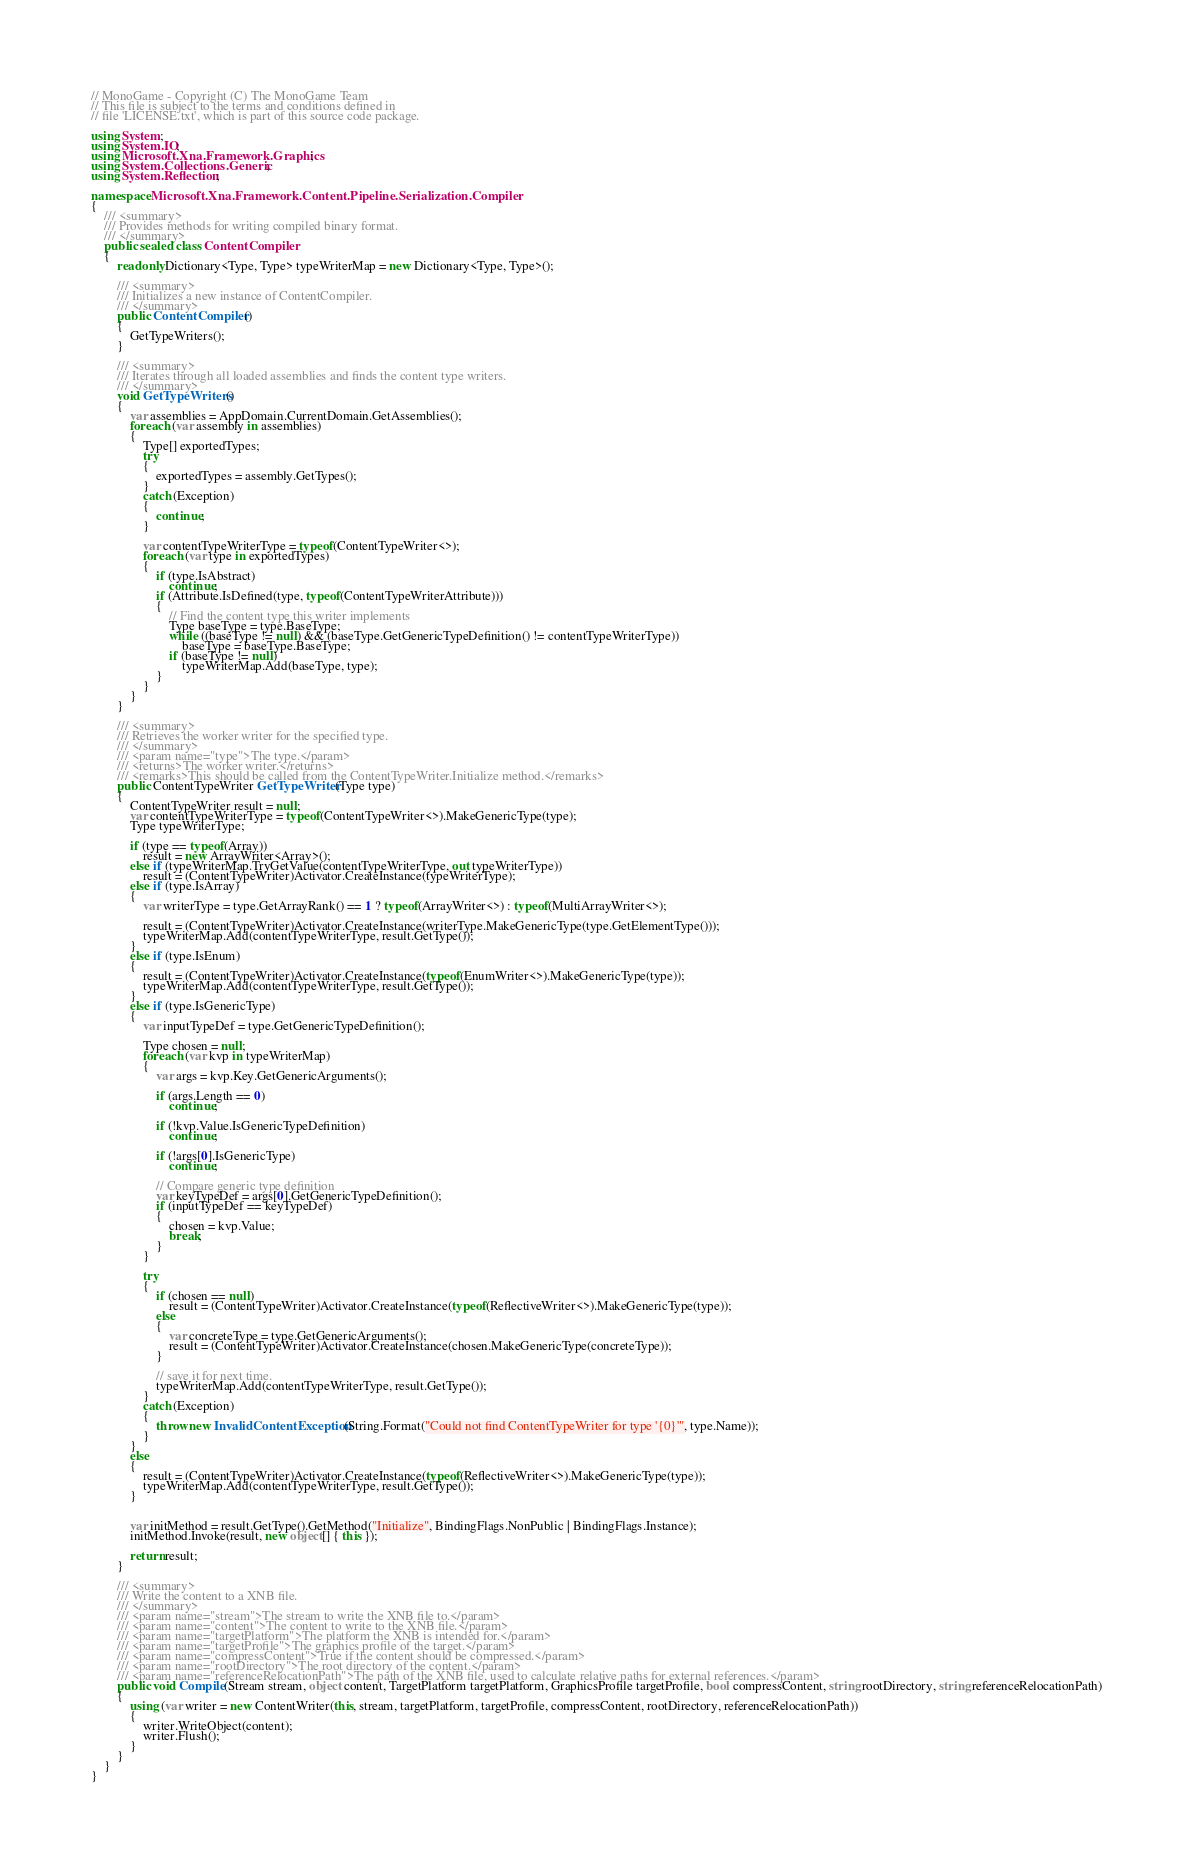Convert code to text. <code><loc_0><loc_0><loc_500><loc_500><_C#_>// MonoGame - Copyright (C) The MonoGame Team
// This file is subject to the terms and conditions defined in
// file 'LICENSE.txt', which is part of this source code package.

using System;
using System.IO;
using Microsoft.Xna.Framework.Graphics;
using System.Collections.Generic;
using System.Reflection;

namespace Microsoft.Xna.Framework.Content.Pipeline.Serialization.Compiler
{
    /// <summary>
    /// Provides methods for writing compiled binary format.
    /// </summary>
    public sealed class ContentCompiler
    {
        readonly Dictionary<Type, Type> typeWriterMap = new Dictionary<Type, Type>();

        /// <summary>
        /// Initializes a new instance of ContentCompiler.
        /// </summary>
        public ContentCompiler()
        {
            GetTypeWriters();
        }

        /// <summary>
        /// Iterates through all loaded assemblies and finds the content type writers.
        /// </summary>
        void GetTypeWriters()
        {
            var assemblies = AppDomain.CurrentDomain.GetAssemblies();
            foreach (var assembly in assemblies)
            {
                Type[] exportedTypes;
                try
                {
                    exportedTypes = assembly.GetTypes();
                }
                catch (Exception)
                {
                    continue;
                }

                var contentTypeWriterType = typeof(ContentTypeWriter<>);
                foreach (var type in exportedTypes)
                {
					if (type.IsAbstract)
                        continue;
                    if (Attribute.IsDefined(type, typeof(ContentTypeWriterAttribute)))
                    {
                        // Find the content type this writer implements
                        Type baseType = type.BaseType;
                        while ((baseType != null) && (baseType.GetGenericTypeDefinition() != contentTypeWriterType))
                            baseType = baseType.BaseType;
                        if (baseType != null)
                            typeWriterMap.Add(baseType, type);
                    }
                }
            }
        }

        /// <summary>
        /// Retrieves the worker writer for the specified type.
        /// </summary>
        /// <param name="type">The type.</param>
        /// <returns>The worker writer.</returns>
        /// <remarks>This should be called from the ContentTypeWriter.Initialize method.</remarks>
        public ContentTypeWriter GetTypeWriter(Type type)
        {
            ContentTypeWriter result = null;
            var contentTypeWriterType = typeof(ContentTypeWriter<>).MakeGenericType(type);
            Type typeWriterType;

            if (type == typeof(Array))
                result = new ArrayWriter<Array>();
            else if (typeWriterMap.TryGetValue(contentTypeWriterType, out typeWriterType))
                result = (ContentTypeWriter)Activator.CreateInstance(typeWriterType);
            else if (type.IsArray)
            {
                var writerType = type.GetArrayRank() == 1 ? typeof(ArrayWriter<>) : typeof(MultiArrayWriter<>);

                result = (ContentTypeWriter)Activator.CreateInstance(writerType.MakeGenericType(type.GetElementType()));
                typeWriterMap.Add(contentTypeWriterType, result.GetType());
            }
            else if (type.IsEnum)
            {
                result = (ContentTypeWriter)Activator.CreateInstance(typeof(EnumWriter<>).MakeGenericType(type));
                typeWriterMap.Add(contentTypeWriterType, result.GetType());
            }
            else if (type.IsGenericType)
            {
                var inputTypeDef = type.GetGenericTypeDefinition();

                Type chosen = null;
                foreach (var kvp in typeWriterMap)
                {
                    var args = kvp.Key.GetGenericArguments();

                    if (args.Length == 0)
                        continue;

                    if (!kvp.Value.IsGenericTypeDefinition)
                        continue;

                    if (!args[0].IsGenericType)
                        continue;

                    // Compare generic type definition
                    var keyTypeDef = args[0].GetGenericTypeDefinition();
                    if (inputTypeDef == keyTypeDef)
                    {
                        chosen = kvp.Value;
                        break;
                    }
                }

                try
                {
                    if (chosen == null)
                        result = (ContentTypeWriter)Activator.CreateInstance(typeof(ReflectiveWriter<>).MakeGenericType(type));
                    else
                    {
                        var concreteType = type.GetGenericArguments();
                        result = (ContentTypeWriter)Activator.CreateInstance(chosen.MakeGenericType(concreteType));
                    }

                    // save it for next time.
                    typeWriterMap.Add(contentTypeWriterType, result.GetType());
                }
                catch (Exception)
                {
                    throw new InvalidContentException(String.Format("Could not find ContentTypeWriter for type '{0}'", type.Name));
                }
            }
            else
            {
                result = (ContentTypeWriter)Activator.CreateInstance(typeof(ReflectiveWriter<>).MakeGenericType(type));
                typeWriterMap.Add(contentTypeWriterType, result.GetType());
            }


            var initMethod = result.GetType().GetMethod("Initialize", BindingFlags.NonPublic | BindingFlags.Instance);
            initMethod.Invoke(result, new object[] { this });

            return result;
        }

        /// <summary>
        /// Write the content to a XNB file.
        /// </summary>
        /// <param name="stream">The stream to write the XNB file to.</param>
        /// <param name="content">The content to write to the XNB file.</param>
        /// <param name="targetPlatform">The platform the XNB is intended for.</param>
        /// <param name="targetProfile">The graphics profile of the target.</param>
        /// <param name="compressContent">True if the content should be compressed.</param>
        /// <param name="rootDirectory">The root directory of the content.</param>
        /// <param name="referenceRelocationPath">The path of the XNB file, used to calculate relative paths for external references.</param>
        public void Compile(Stream stream, object content, TargetPlatform targetPlatform, GraphicsProfile targetProfile, bool compressContent, string rootDirectory, string referenceRelocationPath)
        {
            using (var writer = new ContentWriter(this, stream, targetPlatform, targetProfile, compressContent, rootDirectory, referenceRelocationPath))
            {
                writer.WriteObject(content);
                writer.Flush();
            }
        }
    }
}
</code> 